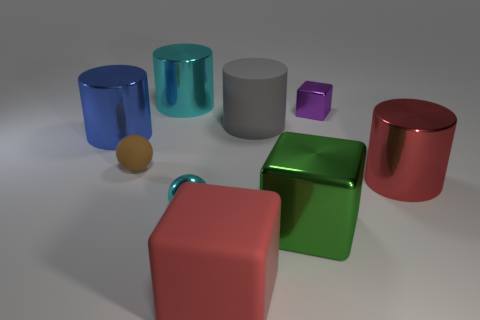Subtract all big green blocks. How many blocks are left? 2 Add 1 red shiny cylinders. How many objects exist? 10 Subtract all cyan balls. How many balls are left? 1 Subtract all cylinders. How many objects are left? 5 Subtract all brown blocks. Subtract all red balls. How many blocks are left? 3 Subtract all red blocks. Subtract all blocks. How many objects are left? 5 Add 4 matte cylinders. How many matte cylinders are left? 5 Add 6 purple metallic blocks. How many purple metallic blocks exist? 7 Subtract 1 cyan spheres. How many objects are left? 8 